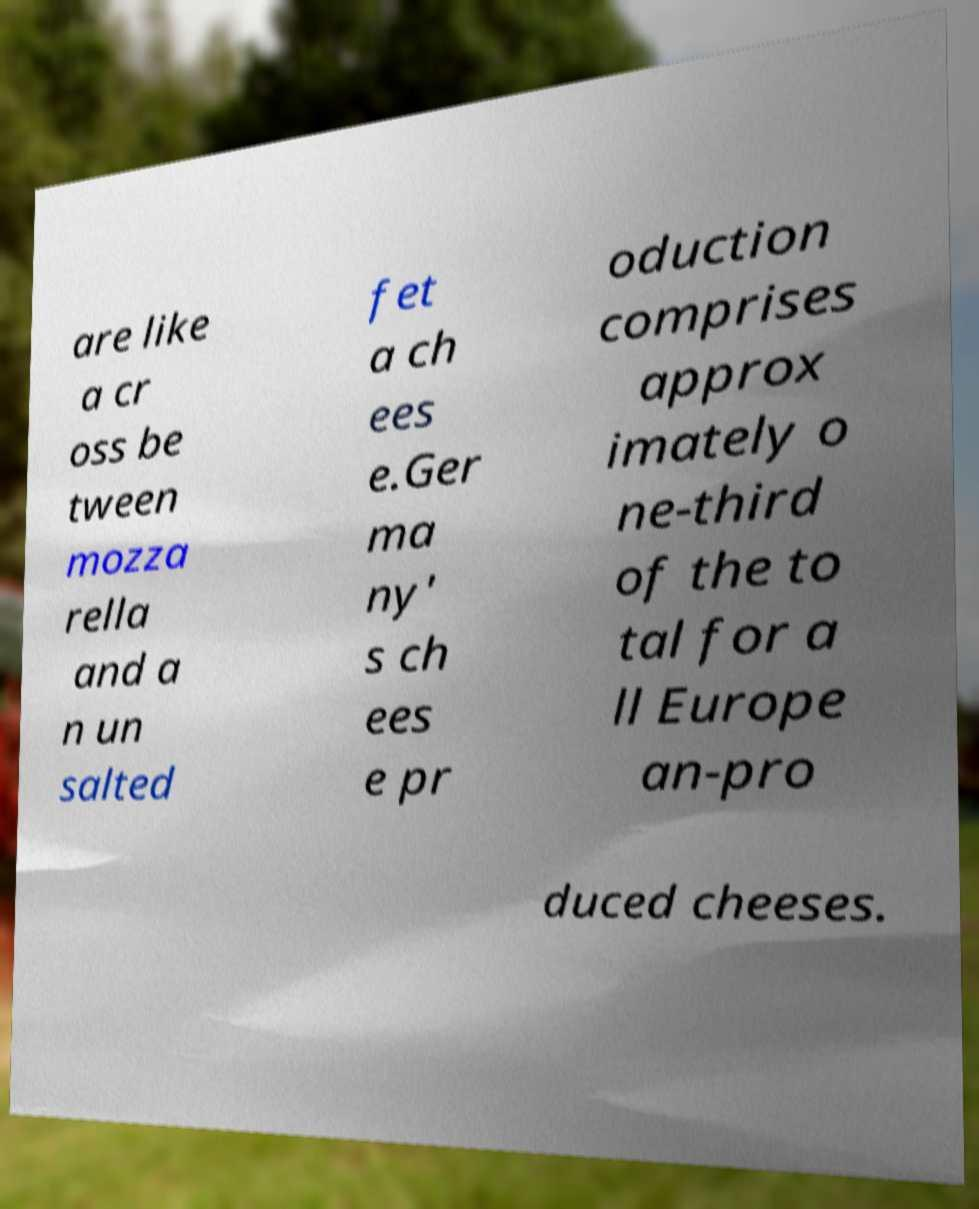For documentation purposes, I need the text within this image transcribed. Could you provide that? are like a cr oss be tween mozza rella and a n un salted fet a ch ees e.Ger ma ny' s ch ees e pr oduction comprises approx imately o ne-third of the to tal for a ll Europe an-pro duced cheeses. 